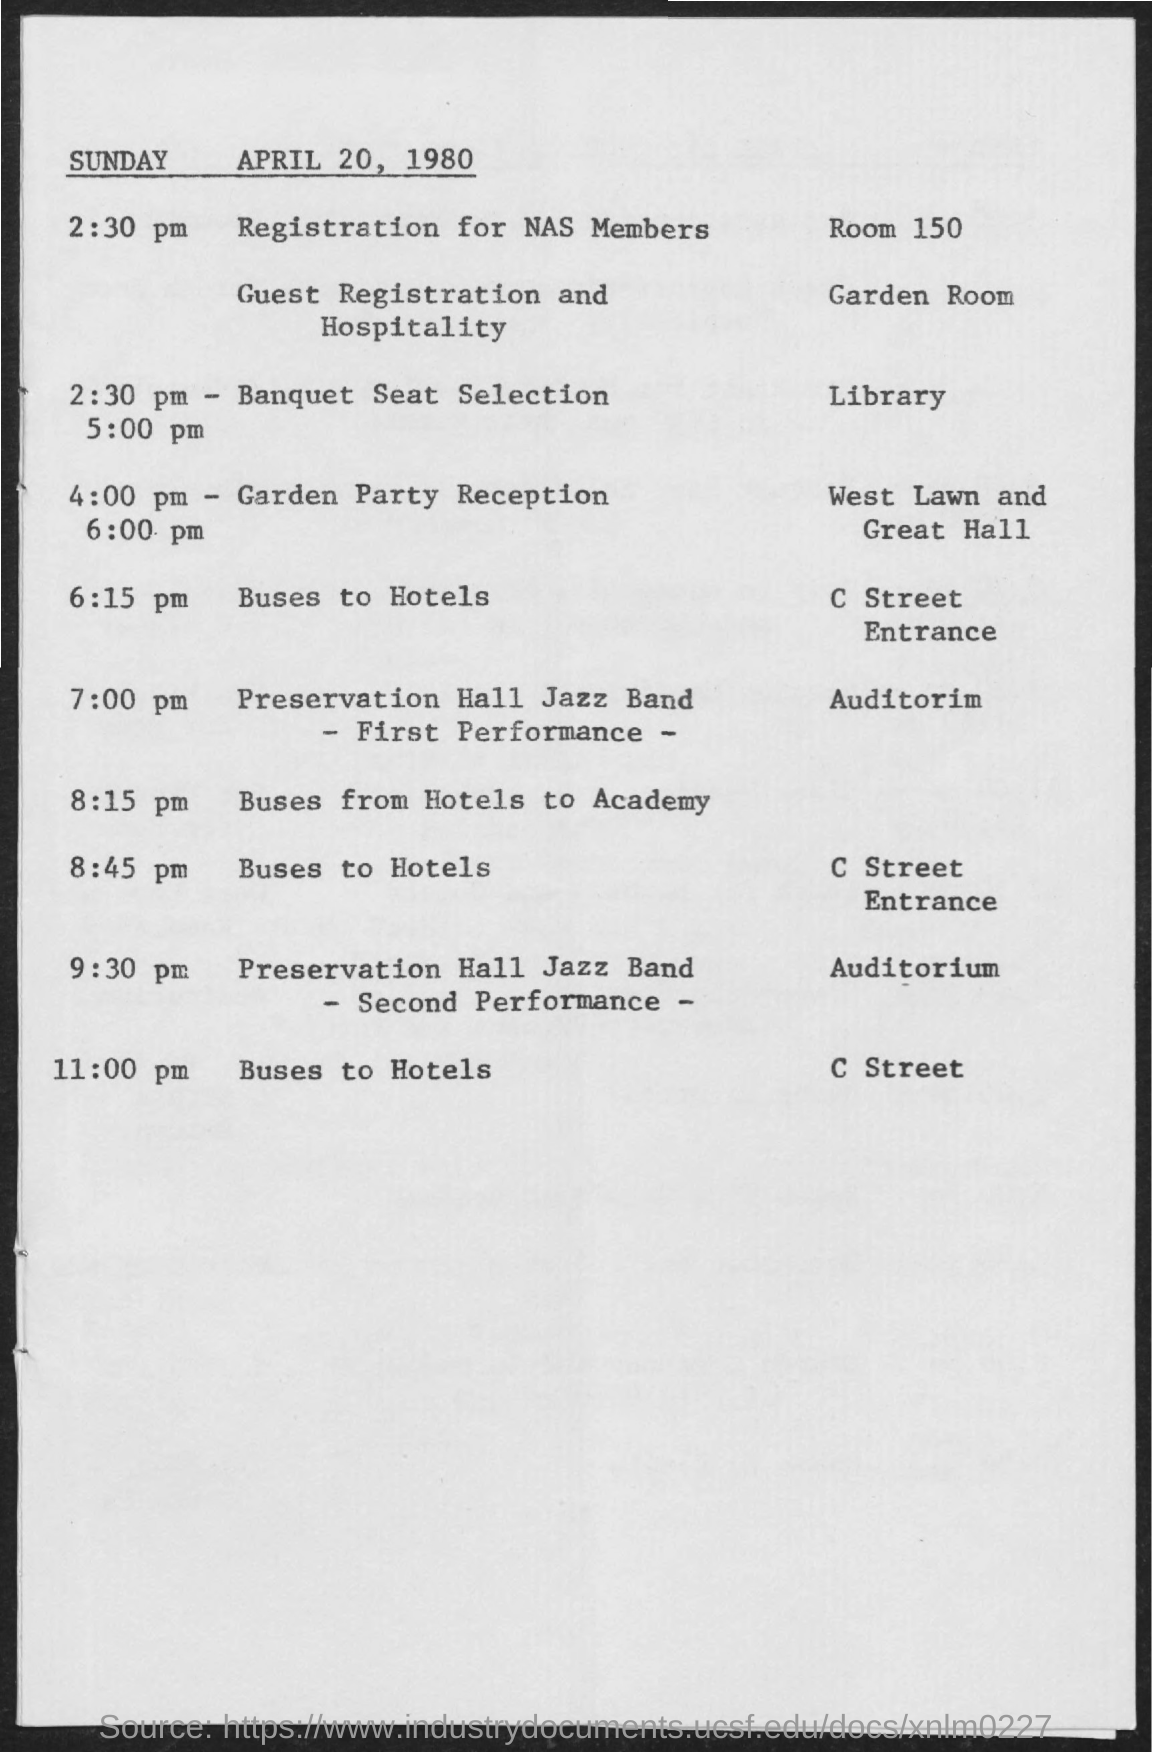What time is the Garden Party Reception organized on Sunday, April 20, 1980?
Your response must be concise. 4:00 PM - 6:00 PM. Where is the Banquet Seat Selection held on Sunday, April 20, 1980?
Give a very brief answer. LIBRARY. 